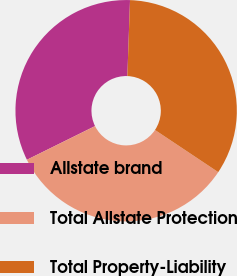Convert chart. <chart><loc_0><loc_0><loc_500><loc_500><pie_chart><fcel>Allstate brand<fcel>Total Allstate Protection<fcel>Total Property-Liability<nl><fcel>32.86%<fcel>33.33%<fcel>33.8%<nl></chart> 